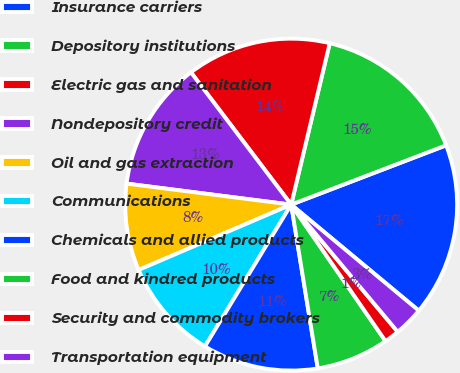Convert chart. <chart><loc_0><loc_0><loc_500><loc_500><pie_chart><fcel>Insurance carriers<fcel>Depository institutions<fcel>Electric gas and sanitation<fcel>Nondepository credit<fcel>Oil and gas extraction<fcel>Communications<fcel>Chemicals and allied products<fcel>Food and kindred products<fcel>Security and commodity brokers<fcel>Transportation equipment<nl><fcel>16.85%<fcel>15.45%<fcel>14.05%<fcel>12.66%<fcel>8.46%<fcel>9.86%<fcel>11.26%<fcel>7.06%<fcel>1.47%<fcel>2.87%<nl></chart> 